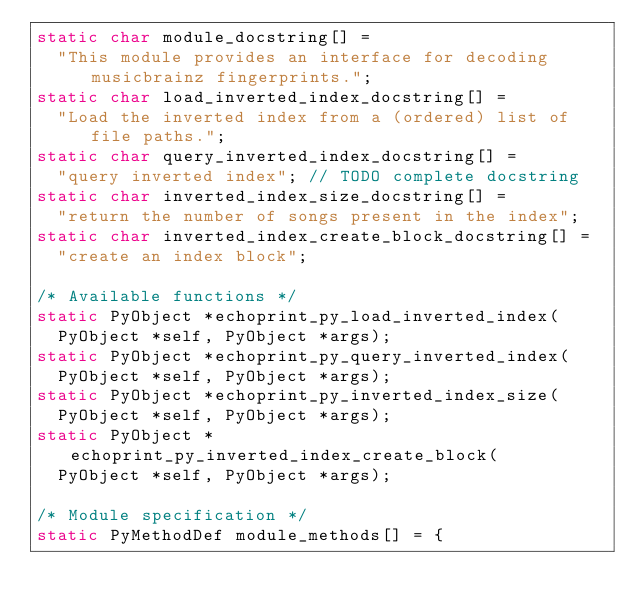Convert code to text. <code><loc_0><loc_0><loc_500><loc_500><_C_>static char module_docstring[] =
  "This module provides an interface for decoding musicbrainz fingerprints.";
static char load_inverted_index_docstring[] =
  "Load the inverted index from a (ordered) list of file paths.";
static char query_inverted_index_docstring[] =
  "query inverted index"; // TODO complete docstring
static char inverted_index_size_docstring[] =
  "return the number of songs present in the index";
static char inverted_index_create_block_docstring[] =
  "create an index block";

/* Available functions */
static PyObject *echoprint_py_load_inverted_index(
  PyObject *self, PyObject *args);
static PyObject *echoprint_py_query_inverted_index(
  PyObject *self, PyObject *args);
static PyObject *echoprint_py_inverted_index_size(
  PyObject *self, PyObject *args);
static PyObject *echoprint_py_inverted_index_create_block(
  PyObject *self, PyObject *args);

/* Module specification */
static PyMethodDef module_methods[] = {</code> 